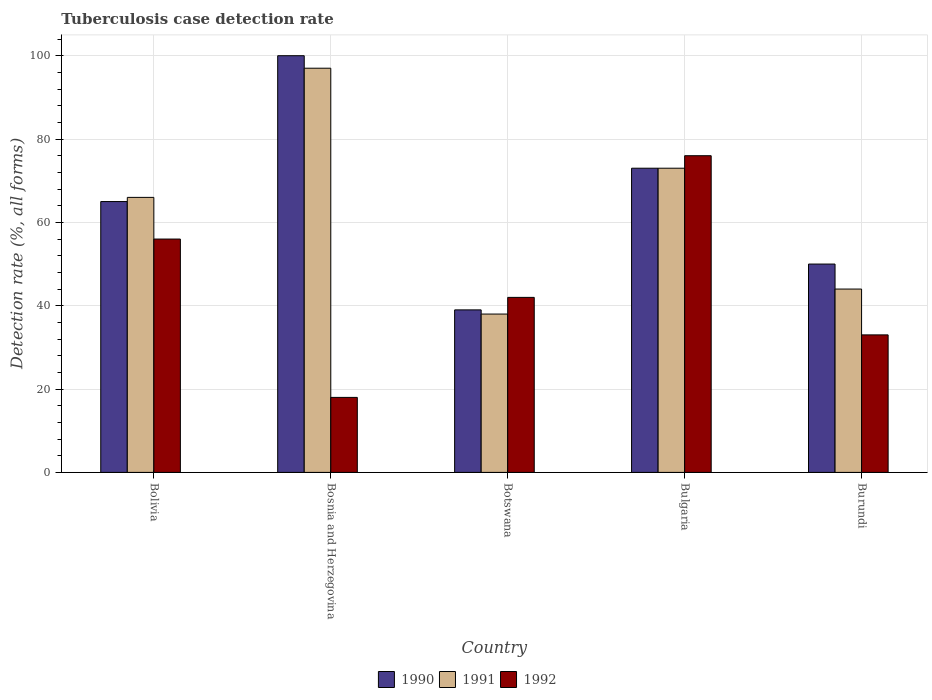How many groups of bars are there?
Make the answer very short. 5. What is the label of the 3rd group of bars from the left?
Your answer should be compact. Botswana. Across all countries, what is the maximum tuberculosis case detection rate in in 1991?
Offer a terse response. 97. Across all countries, what is the minimum tuberculosis case detection rate in in 1992?
Provide a short and direct response. 18. In which country was the tuberculosis case detection rate in in 1991 maximum?
Provide a succinct answer. Bosnia and Herzegovina. In which country was the tuberculosis case detection rate in in 1992 minimum?
Ensure brevity in your answer.  Bosnia and Herzegovina. What is the total tuberculosis case detection rate in in 1992 in the graph?
Give a very brief answer. 225. What is the difference between the tuberculosis case detection rate in in 1990 in Bolivia and that in Burundi?
Give a very brief answer. 15. What is the average tuberculosis case detection rate in in 1990 per country?
Give a very brief answer. 65.4. What is the ratio of the tuberculosis case detection rate in in 1991 in Bolivia to that in Bosnia and Herzegovina?
Ensure brevity in your answer.  0.68. Is the tuberculosis case detection rate in in 1991 in Bosnia and Herzegovina less than that in Botswana?
Offer a terse response. No. What is the difference between the highest and the second highest tuberculosis case detection rate in in 1991?
Offer a very short reply. -24. What is the difference between the highest and the lowest tuberculosis case detection rate in in 1992?
Provide a short and direct response. 58. In how many countries, is the tuberculosis case detection rate in in 1990 greater than the average tuberculosis case detection rate in in 1990 taken over all countries?
Your response must be concise. 2. Is the sum of the tuberculosis case detection rate in in 1990 in Bosnia and Herzegovina and Burundi greater than the maximum tuberculosis case detection rate in in 1991 across all countries?
Keep it short and to the point. Yes. What does the 2nd bar from the left in Bosnia and Herzegovina represents?
Provide a succinct answer. 1991. What does the 1st bar from the right in Bolivia represents?
Ensure brevity in your answer.  1992. Are all the bars in the graph horizontal?
Make the answer very short. No. How many countries are there in the graph?
Your answer should be very brief. 5. What is the difference between two consecutive major ticks on the Y-axis?
Offer a terse response. 20. Are the values on the major ticks of Y-axis written in scientific E-notation?
Provide a succinct answer. No. Where does the legend appear in the graph?
Give a very brief answer. Bottom center. What is the title of the graph?
Make the answer very short. Tuberculosis case detection rate. What is the label or title of the Y-axis?
Give a very brief answer. Detection rate (%, all forms). What is the Detection rate (%, all forms) of 1991 in Bolivia?
Provide a short and direct response. 66. What is the Detection rate (%, all forms) of 1990 in Bosnia and Herzegovina?
Your answer should be compact. 100. What is the Detection rate (%, all forms) of 1991 in Bosnia and Herzegovina?
Offer a terse response. 97. What is the Detection rate (%, all forms) in 1992 in Bosnia and Herzegovina?
Provide a succinct answer. 18. What is the Detection rate (%, all forms) of 1990 in Botswana?
Provide a short and direct response. 39. What is the Detection rate (%, all forms) of 1990 in Bulgaria?
Ensure brevity in your answer.  73. What is the Detection rate (%, all forms) of 1991 in Bulgaria?
Your answer should be very brief. 73. What is the Detection rate (%, all forms) in 1992 in Bulgaria?
Ensure brevity in your answer.  76. Across all countries, what is the maximum Detection rate (%, all forms) of 1990?
Keep it short and to the point. 100. Across all countries, what is the maximum Detection rate (%, all forms) in 1991?
Provide a succinct answer. 97. Across all countries, what is the minimum Detection rate (%, all forms) in 1990?
Your response must be concise. 39. Across all countries, what is the minimum Detection rate (%, all forms) of 1991?
Your answer should be compact. 38. What is the total Detection rate (%, all forms) in 1990 in the graph?
Provide a succinct answer. 327. What is the total Detection rate (%, all forms) of 1991 in the graph?
Keep it short and to the point. 318. What is the total Detection rate (%, all forms) of 1992 in the graph?
Ensure brevity in your answer.  225. What is the difference between the Detection rate (%, all forms) in 1990 in Bolivia and that in Bosnia and Herzegovina?
Make the answer very short. -35. What is the difference between the Detection rate (%, all forms) of 1991 in Bolivia and that in Bosnia and Herzegovina?
Make the answer very short. -31. What is the difference between the Detection rate (%, all forms) in 1992 in Bolivia and that in Bosnia and Herzegovina?
Give a very brief answer. 38. What is the difference between the Detection rate (%, all forms) in 1992 in Bolivia and that in Botswana?
Provide a short and direct response. 14. What is the difference between the Detection rate (%, all forms) in 1990 in Bolivia and that in Bulgaria?
Provide a succinct answer. -8. What is the difference between the Detection rate (%, all forms) of 1991 in Bolivia and that in Bulgaria?
Offer a very short reply. -7. What is the difference between the Detection rate (%, all forms) in 1992 in Bolivia and that in Bulgaria?
Offer a very short reply. -20. What is the difference between the Detection rate (%, all forms) of 1990 in Bolivia and that in Burundi?
Make the answer very short. 15. What is the difference between the Detection rate (%, all forms) of 1991 in Bolivia and that in Burundi?
Give a very brief answer. 22. What is the difference between the Detection rate (%, all forms) of 1992 in Bolivia and that in Burundi?
Keep it short and to the point. 23. What is the difference between the Detection rate (%, all forms) of 1990 in Bosnia and Herzegovina and that in Bulgaria?
Provide a short and direct response. 27. What is the difference between the Detection rate (%, all forms) of 1991 in Bosnia and Herzegovina and that in Bulgaria?
Ensure brevity in your answer.  24. What is the difference between the Detection rate (%, all forms) in 1992 in Bosnia and Herzegovina and that in Bulgaria?
Give a very brief answer. -58. What is the difference between the Detection rate (%, all forms) of 1990 in Bosnia and Herzegovina and that in Burundi?
Give a very brief answer. 50. What is the difference between the Detection rate (%, all forms) in 1991 in Bosnia and Herzegovina and that in Burundi?
Offer a very short reply. 53. What is the difference between the Detection rate (%, all forms) of 1992 in Bosnia and Herzegovina and that in Burundi?
Offer a terse response. -15. What is the difference between the Detection rate (%, all forms) in 1990 in Botswana and that in Bulgaria?
Provide a succinct answer. -34. What is the difference between the Detection rate (%, all forms) in 1991 in Botswana and that in Bulgaria?
Ensure brevity in your answer.  -35. What is the difference between the Detection rate (%, all forms) of 1992 in Botswana and that in Bulgaria?
Offer a very short reply. -34. What is the difference between the Detection rate (%, all forms) of 1990 in Botswana and that in Burundi?
Provide a succinct answer. -11. What is the difference between the Detection rate (%, all forms) in 1991 in Botswana and that in Burundi?
Offer a terse response. -6. What is the difference between the Detection rate (%, all forms) in 1990 in Bulgaria and that in Burundi?
Offer a terse response. 23. What is the difference between the Detection rate (%, all forms) in 1991 in Bulgaria and that in Burundi?
Provide a succinct answer. 29. What is the difference between the Detection rate (%, all forms) in 1990 in Bolivia and the Detection rate (%, all forms) in 1991 in Bosnia and Herzegovina?
Your response must be concise. -32. What is the difference between the Detection rate (%, all forms) of 1990 in Bolivia and the Detection rate (%, all forms) of 1992 in Bulgaria?
Offer a terse response. -11. What is the difference between the Detection rate (%, all forms) of 1990 in Bolivia and the Detection rate (%, all forms) of 1991 in Burundi?
Give a very brief answer. 21. What is the difference between the Detection rate (%, all forms) of 1991 in Bolivia and the Detection rate (%, all forms) of 1992 in Burundi?
Provide a succinct answer. 33. What is the difference between the Detection rate (%, all forms) of 1991 in Bosnia and Herzegovina and the Detection rate (%, all forms) of 1992 in Botswana?
Your response must be concise. 55. What is the difference between the Detection rate (%, all forms) in 1990 in Bosnia and Herzegovina and the Detection rate (%, all forms) in 1992 in Bulgaria?
Keep it short and to the point. 24. What is the difference between the Detection rate (%, all forms) in 1990 in Botswana and the Detection rate (%, all forms) in 1991 in Bulgaria?
Keep it short and to the point. -34. What is the difference between the Detection rate (%, all forms) in 1990 in Botswana and the Detection rate (%, all forms) in 1992 in Bulgaria?
Your answer should be compact. -37. What is the difference between the Detection rate (%, all forms) in 1991 in Botswana and the Detection rate (%, all forms) in 1992 in Bulgaria?
Your answer should be compact. -38. What is the difference between the Detection rate (%, all forms) in 1990 in Botswana and the Detection rate (%, all forms) in 1992 in Burundi?
Offer a terse response. 6. What is the difference between the Detection rate (%, all forms) of 1991 in Botswana and the Detection rate (%, all forms) of 1992 in Burundi?
Make the answer very short. 5. What is the average Detection rate (%, all forms) of 1990 per country?
Make the answer very short. 65.4. What is the average Detection rate (%, all forms) in 1991 per country?
Your response must be concise. 63.6. What is the average Detection rate (%, all forms) in 1992 per country?
Your answer should be compact. 45. What is the difference between the Detection rate (%, all forms) of 1990 and Detection rate (%, all forms) of 1991 in Bolivia?
Make the answer very short. -1. What is the difference between the Detection rate (%, all forms) in 1991 and Detection rate (%, all forms) in 1992 in Bolivia?
Make the answer very short. 10. What is the difference between the Detection rate (%, all forms) of 1990 and Detection rate (%, all forms) of 1992 in Bosnia and Herzegovina?
Offer a terse response. 82. What is the difference between the Detection rate (%, all forms) in 1991 and Detection rate (%, all forms) in 1992 in Bosnia and Herzegovina?
Give a very brief answer. 79. What is the difference between the Detection rate (%, all forms) in 1990 and Detection rate (%, all forms) in 1991 in Botswana?
Offer a very short reply. 1. What is the difference between the Detection rate (%, all forms) in 1990 and Detection rate (%, all forms) in 1991 in Bulgaria?
Offer a very short reply. 0. What is the difference between the Detection rate (%, all forms) in 1990 and Detection rate (%, all forms) in 1991 in Burundi?
Your answer should be very brief. 6. What is the difference between the Detection rate (%, all forms) of 1990 and Detection rate (%, all forms) of 1992 in Burundi?
Your answer should be very brief. 17. What is the ratio of the Detection rate (%, all forms) in 1990 in Bolivia to that in Bosnia and Herzegovina?
Provide a short and direct response. 0.65. What is the ratio of the Detection rate (%, all forms) of 1991 in Bolivia to that in Bosnia and Herzegovina?
Make the answer very short. 0.68. What is the ratio of the Detection rate (%, all forms) of 1992 in Bolivia to that in Bosnia and Herzegovina?
Keep it short and to the point. 3.11. What is the ratio of the Detection rate (%, all forms) of 1990 in Bolivia to that in Botswana?
Your response must be concise. 1.67. What is the ratio of the Detection rate (%, all forms) of 1991 in Bolivia to that in Botswana?
Offer a very short reply. 1.74. What is the ratio of the Detection rate (%, all forms) in 1992 in Bolivia to that in Botswana?
Your response must be concise. 1.33. What is the ratio of the Detection rate (%, all forms) of 1990 in Bolivia to that in Bulgaria?
Provide a short and direct response. 0.89. What is the ratio of the Detection rate (%, all forms) in 1991 in Bolivia to that in Bulgaria?
Your response must be concise. 0.9. What is the ratio of the Detection rate (%, all forms) of 1992 in Bolivia to that in Bulgaria?
Your answer should be compact. 0.74. What is the ratio of the Detection rate (%, all forms) in 1991 in Bolivia to that in Burundi?
Provide a short and direct response. 1.5. What is the ratio of the Detection rate (%, all forms) of 1992 in Bolivia to that in Burundi?
Your answer should be compact. 1.7. What is the ratio of the Detection rate (%, all forms) in 1990 in Bosnia and Herzegovina to that in Botswana?
Your answer should be very brief. 2.56. What is the ratio of the Detection rate (%, all forms) of 1991 in Bosnia and Herzegovina to that in Botswana?
Give a very brief answer. 2.55. What is the ratio of the Detection rate (%, all forms) of 1992 in Bosnia and Herzegovina to that in Botswana?
Provide a short and direct response. 0.43. What is the ratio of the Detection rate (%, all forms) in 1990 in Bosnia and Herzegovina to that in Bulgaria?
Your answer should be compact. 1.37. What is the ratio of the Detection rate (%, all forms) of 1991 in Bosnia and Herzegovina to that in Bulgaria?
Your response must be concise. 1.33. What is the ratio of the Detection rate (%, all forms) of 1992 in Bosnia and Herzegovina to that in Bulgaria?
Make the answer very short. 0.24. What is the ratio of the Detection rate (%, all forms) of 1991 in Bosnia and Herzegovina to that in Burundi?
Offer a very short reply. 2.2. What is the ratio of the Detection rate (%, all forms) in 1992 in Bosnia and Herzegovina to that in Burundi?
Your response must be concise. 0.55. What is the ratio of the Detection rate (%, all forms) in 1990 in Botswana to that in Bulgaria?
Ensure brevity in your answer.  0.53. What is the ratio of the Detection rate (%, all forms) in 1991 in Botswana to that in Bulgaria?
Provide a short and direct response. 0.52. What is the ratio of the Detection rate (%, all forms) of 1992 in Botswana to that in Bulgaria?
Give a very brief answer. 0.55. What is the ratio of the Detection rate (%, all forms) in 1990 in Botswana to that in Burundi?
Your response must be concise. 0.78. What is the ratio of the Detection rate (%, all forms) in 1991 in Botswana to that in Burundi?
Provide a succinct answer. 0.86. What is the ratio of the Detection rate (%, all forms) of 1992 in Botswana to that in Burundi?
Your response must be concise. 1.27. What is the ratio of the Detection rate (%, all forms) of 1990 in Bulgaria to that in Burundi?
Ensure brevity in your answer.  1.46. What is the ratio of the Detection rate (%, all forms) of 1991 in Bulgaria to that in Burundi?
Provide a short and direct response. 1.66. What is the ratio of the Detection rate (%, all forms) in 1992 in Bulgaria to that in Burundi?
Make the answer very short. 2.3. What is the difference between the highest and the second highest Detection rate (%, all forms) of 1990?
Your answer should be compact. 27. What is the difference between the highest and the lowest Detection rate (%, all forms) in 1990?
Give a very brief answer. 61. What is the difference between the highest and the lowest Detection rate (%, all forms) in 1991?
Provide a short and direct response. 59. 